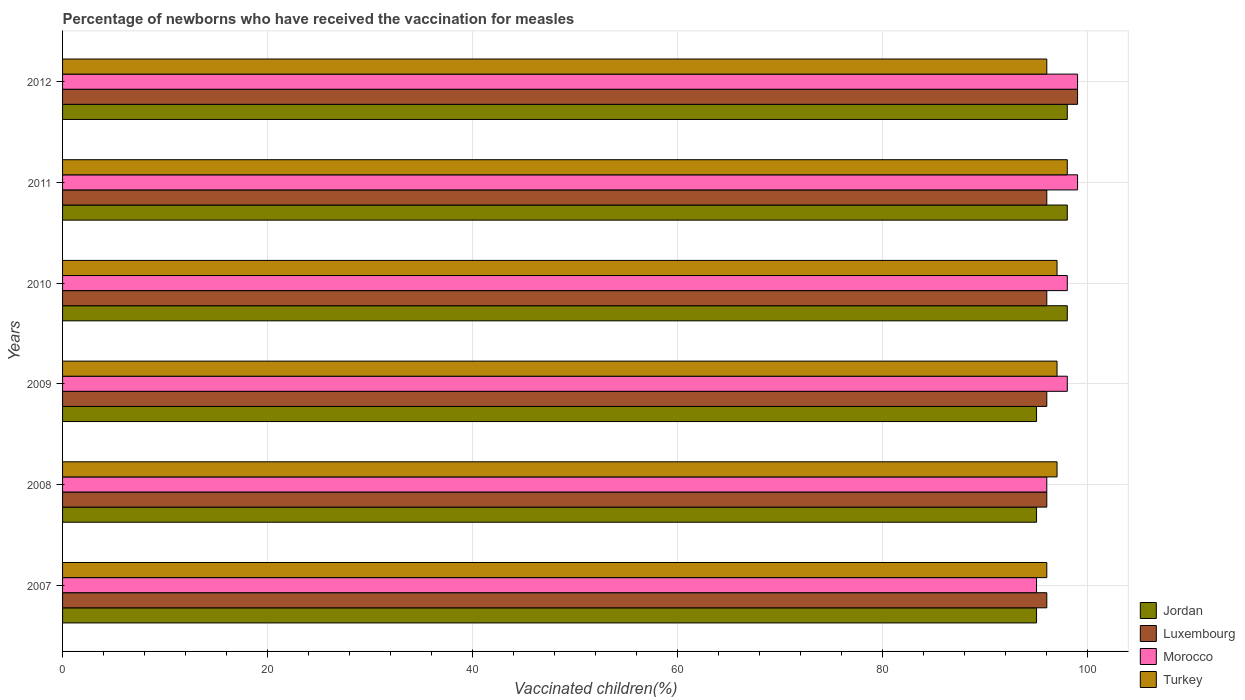How many different coloured bars are there?
Provide a short and direct response. 4. Are the number of bars on each tick of the Y-axis equal?
Your answer should be very brief. Yes. How many bars are there on the 2nd tick from the top?
Keep it short and to the point. 4. In how many cases, is the number of bars for a given year not equal to the number of legend labels?
Offer a terse response. 0. What is the percentage of vaccinated children in Turkey in 2012?
Offer a very short reply. 96. Across all years, what is the maximum percentage of vaccinated children in Turkey?
Your response must be concise. 98. Across all years, what is the minimum percentage of vaccinated children in Luxembourg?
Give a very brief answer. 96. In which year was the percentage of vaccinated children in Morocco maximum?
Your answer should be compact. 2011. In which year was the percentage of vaccinated children in Morocco minimum?
Make the answer very short. 2007. What is the total percentage of vaccinated children in Morocco in the graph?
Your response must be concise. 585. What is the difference between the percentage of vaccinated children in Turkey in 2008 and that in 2012?
Offer a very short reply. 1. What is the average percentage of vaccinated children in Morocco per year?
Your response must be concise. 97.5. In the year 2011, what is the difference between the percentage of vaccinated children in Luxembourg and percentage of vaccinated children in Jordan?
Give a very brief answer. -2. In how many years, is the percentage of vaccinated children in Turkey greater than 60 %?
Ensure brevity in your answer.  6. What is the ratio of the percentage of vaccinated children in Turkey in 2009 to that in 2011?
Provide a short and direct response. 0.99. Is the percentage of vaccinated children in Turkey in 2009 less than that in 2011?
Provide a short and direct response. Yes. What is the difference between the highest and the lowest percentage of vaccinated children in Morocco?
Offer a terse response. 4. In how many years, is the percentage of vaccinated children in Jordan greater than the average percentage of vaccinated children in Jordan taken over all years?
Your response must be concise. 3. Is the sum of the percentage of vaccinated children in Turkey in 2008 and 2012 greater than the maximum percentage of vaccinated children in Morocco across all years?
Offer a very short reply. Yes. What does the 3rd bar from the bottom in 2007 represents?
Offer a terse response. Morocco. Are all the bars in the graph horizontal?
Offer a terse response. Yes. Does the graph contain any zero values?
Offer a terse response. No. Where does the legend appear in the graph?
Offer a terse response. Bottom right. What is the title of the graph?
Provide a succinct answer. Percentage of newborns who have received the vaccination for measles. Does "Macedonia" appear as one of the legend labels in the graph?
Your response must be concise. No. What is the label or title of the X-axis?
Give a very brief answer. Vaccinated children(%). What is the Vaccinated children(%) in Jordan in 2007?
Keep it short and to the point. 95. What is the Vaccinated children(%) of Luxembourg in 2007?
Your answer should be very brief. 96. What is the Vaccinated children(%) of Morocco in 2007?
Your response must be concise. 95. What is the Vaccinated children(%) in Turkey in 2007?
Offer a terse response. 96. What is the Vaccinated children(%) in Luxembourg in 2008?
Provide a succinct answer. 96. What is the Vaccinated children(%) in Morocco in 2008?
Your response must be concise. 96. What is the Vaccinated children(%) of Turkey in 2008?
Provide a short and direct response. 97. What is the Vaccinated children(%) of Jordan in 2009?
Offer a terse response. 95. What is the Vaccinated children(%) in Luxembourg in 2009?
Provide a succinct answer. 96. What is the Vaccinated children(%) in Morocco in 2009?
Provide a succinct answer. 98. What is the Vaccinated children(%) of Turkey in 2009?
Your response must be concise. 97. What is the Vaccinated children(%) in Luxembourg in 2010?
Offer a very short reply. 96. What is the Vaccinated children(%) of Turkey in 2010?
Keep it short and to the point. 97. What is the Vaccinated children(%) in Jordan in 2011?
Your response must be concise. 98. What is the Vaccinated children(%) of Luxembourg in 2011?
Your answer should be very brief. 96. What is the Vaccinated children(%) of Morocco in 2011?
Your answer should be very brief. 99. What is the Vaccinated children(%) in Luxembourg in 2012?
Keep it short and to the point. 99. What is the Vaccinated children(%) in Morocco in 2012?
Your response must be concise. 99. What is the Vaccinated children(%) of Turkey in 2012?
Your answer should be very brief. 96. Across all years, what is the maximum Vaccinated children(%) in Luxembourg?
Offer a very short reply. 99. Across all years, what is the maximum Vaccinated children(%) in Morocco?
Your answer should be very brief. 99. Across all years, what is the maximum Vaccinated children(%) in Turkey?
Provide a short and direct response. 98. Across all years, what is the minimum Vaccinated children(%) of Luxembourg?
Offer a very short reply. 96. Across all years, what is the minimum Vaccinated children(%) in Morocco?
Offer a very short reply. 95. Across all years, what is the minimum Vaccinated children(%) in Turkey?
Offer a very short reply. 96. What is the total Vaccinated children(%) in Jordan in the graph?
Give a very brief answer. 579. What is the total Vaccinated children(%) in Luxembourg in the graph?
Keep it short and to the point. 579. What is the total Vaccinated children(%) in Morocco in the graph?
Keep it short and to the point. 585. What is the total Vaccinated children(%) of Turkey in the graph?
Provide a short and direct response. 581. What is the difference between the Vaccinated children(%) in Turkey in 2007 and that in 2009?
Provide a short and direct response. -1. What is the difference between the Vaccinated children(%) of Jordan in 2007 and that in 2010?
Provide a succinct answer. -3. What is the difference between the Vaccinated children(%) of Luxembourg in 2007 and that in 2011?
Ensure brevity in your answer.  0. What is the difference between the Vaccinated children(%) of Turkey in 2007 and that in 2011?
Your answer should be compact. -2. What is the difference between the Vaccinated children(%) of Luxembourg in 2007 and that in 2012?
Provide a succinct answer. -3. What is the difference between the Vaccinated children(%) in Morocco in 2007 and that in 2012?
Your answer should be very brief. -4. What is the difference between the Vaccinated children(%) of Turkey in 2007 and that in 2012?
Your answer should be compact. 0. What is the difference between the Vaccinated children(%) in Jordan in 2008 and that in 2009?
Offer a terse response. 0. What is the difference between the Vaccinated children(%) in Luxembourg in 2008 and that in 2009?
Your answer should be very brief. 0. What is the difference between the Vaccinated children(%) of Morocco in 2008 and that in 2010?
Keep it short and to the point. -2. What is the difference between the Vaccinated children(%) in Turkey in 2008 and that in 2010?
Ensure brevity in your answer.  0. What is the difference between the Vaccinated children(%) in Jordan in 2008 and that in 2011?
Your response must be concise. -3. What is the difference between the Vaccinated children(%) of Luxembourg in 2008 and that in 2011?
Offer a very short reply. 0. What is the difference between the Vaccinated children(%) of Turkey in 2008 and that in 2011?
Offer a very short reply. -1. What is the difference between the Vaccinated children(%) in Luxembourg in 2008 and that in 2012?
Make the answer very short. -3. What is the difference between the Vaccinated children(%) of Morocco in 2008 and that in 2012?
Ensure brevity in your answer.  -3. What is the difference between the Vaccinated children(%) of Turkey in 2009 and that in 2010?
Provide a short and direct response. 0. What is the difference between the Vaccinated children(%) in Jordan in 2009 and that in 2011?
Provide a short and direct response. -3. What is the difference between the Vaccinated children(%) of Luxembourg in 2009 and that in 2011?
Make the answer very short. 0. What is the difference between the Vaccinated children(%) of Morocco in 2009 and that in 2011?
Your answer should be compact. -1. What is the difference between the Vaccinated children(%) in Jordan in 2009 and that in 2012?
Give a very brief answer. -3. What is the difference between the Vaccinated children(%) of Turkey in 2009 and that in 2012?
Your answer should be compact. 1. What is the difference between the Vaccinated children(%) of Luxembourg in 2010 and that in 2011?
Your answer should be compact. 0. What is the difference between the Vaccinated children(%) in Morocco in 2010 and that in 2011?
Provide a short and direct response. -1. What is the difference between the Vaccinated children(%) of Turkey in 2010 and that in 2011?
Your response must be concise. -1. What is the difference between the Vaccinated children(%) in Jordan in 2010 and that in 2012?
Ensure brevity in your answer.  0. What is the difference between the Vaccinated children(%) in Luxembourg in 2010 and that in 2012?
Provide a succinct answer. -3. What is the difference between the Vaccinated children(%) of Turkey in 2010 and that in 2012?
Offer a very short reply. 1. What is the difference between the Vaccinated children(%) in Luxembourg in 2011 and that in 2012?
Your response must be concise. -3. What is the difference between the Vaccinated children(%) in Turkey in 2011 and that in 2012?
Your answer should be very brief. 2. What is the difference between the Vaccinated children(%) of Jordan in 2007 and the Vaccinated children(%) of Luxembourg in 2008?
Your answer should be compact. -1. What is the difference between the Vaccinated children(%) of Luxembourg in 2007 and the Vaccinated children(%) of Morocco in 2008?
Provide a succinct answer. 0. What is the difference between the Vaccinated children(%) in Jordan in 2007 and the Vaccinated children(%) in Luxembourg in 2009?
Make the answer very short. -1. What is the difference between the Vaccinated children(%) of Jordan in 2007 and the Vaccinated children(%) of Morocco in 2009?
Give a very brief answer. -3. What is the difference between the Vaccinated children(%) in Luxembourg in 2007 and the Vaccinated children(%) in Turkey in 2009?
Give a very brief answer. -1. What is the difference between the Vaccinated children(%) in Morocco in 2007 and the Vaccinated children(%) in Turkey in 2009?
Your answer should be very brief. -2. What is the difference between the Vaccinated children(%) in Jordan in 2007 and the Vaccinated children(%) in Morocco in 2010?
Provide a succinct answer. -3. What is the difference between the Vaccinated children(%) in Jordan in 2007 and the Vaccinated children(%) in Turkey in 2010?
Your answer should be compact. -2. What is the difference between the Vaccinated children(%) of Jordan in 2007 and the Vaccinated children(%) of Morocco in 2011?
Provide a succinct answer. -4. What is the difference between the Vaccinated children(%) of Morocco in 2007 and the Vaccinated children(%) of Turkey in 2011?
Keep it short and to the point. -3. What is the difference between the Vaccinated children(%) in Jordan in 2007 and the Vaccinated children(%) in Luxembourg in 2012?
Provide a short and direct response. -4. What is the difference between the Vaccinated children(%) of Jordan in 2007 and the Vaccinated children(%) of Morocco in 2012?
Ensure brevity in your answer.  -4. What is the difference between the Vaccinated children(%) in Luxembourg in 2007 and the Vaccinated children(%) in Turkey in 2012?
Ensure brevity in your answer.  0. What is the difference between the Vaccinated children(%) in Morocco in 2007 and the Vaccinated children(%) in Turkey in 2012?
Make the answer very short. -1. What is the difference between the Vaccinated children(%) of Jordan in 2008 and the Vaccinated children(%) of Luxembourg in 2009?
Provide a succinct answer. -1. What is the difference between the Vaccinated children(%) of Luxembourg in 2008 and the Vaccinated children(%) of Turkey in 2009?
Your response must be concise. -1. What is the difference between the Vaccinated children(%) of Jordan in 2008 and the Vaccinated children(%) of Luxembourg in 2010?
Your answer should be very brief. -1. What is the difference between the Vaccinated children(%) of Jordan in 2008 and the Vaccinated children(%) of Morocco in 2010?
Give a very brief answer. -3. What is the difference between the Vaccinated children(%) in Luxembourg in 2008 and the Vaccinated children(%) in Morocco in 2010?
Your answer should be compact. -2. What is the difference between the Vaccinated children(%) in Jordan in 2008 and the Vaccinated children(%) in Luxembourg in 2011?
Offer a very short reply. -1. What is the difference between the Vaccinated children(%) in Jordan in 2008 and the Vaccinated children(%) in Turkey in 2011?
Ensure brevity in your answer.  -3. What is the difference between the Vaccinated children(%) in Luxembourg in 2008 and the Vaccinated children(%) in Morocco in 2011?
Ensure brevity in your answer.  -3. What is the difference between the Vaccinated children(%) of Luxembourg in 2008 and the Vaccinated children(%) of Turkey in 2011?
Offer a very short reply. -2. What is the difference between the Vaccinated children(%) in Morocco in 2008 and the Vaccinated children(%) in Turkey in 2011?
Your answer should be very brief. -2. What is the difference between the Vaccinated children(%) in Luxembourg in 2008 and the Vaccinated children(%) in Morocco in 2012?
Provide a short and direct response. -3. What is the difference between the Vaccinated children(%) in Luxembourg in 2008 and the Vaccinated children(%) in Turkey in 2012?
Your answer should be very brief. 0. What is the difference between the Vaccinated children(%) of Morocco in 2008 and the Vaccinated children(%) of Turkey in 2012?
Keep it short and to the point. 0. What is the difference between the Vaccinated children(%) of Jordan in 2009 and the Vaccinated children(%) of Turkey in 2010?
Provide a succinct answer. -2. What is the difference between the Vaccinated children(%) in Luxembourg in 2009 and the Vaccinated children(%) in Morocco in 2010?
Provide a succinct answer. -2. What is the difference between the Vaccinated children(%) in Jordan in 2009 and the Vaccinated children(%) in Morocco in 2011?
Ensure brevity in your answer.  -4. What is the difference between the Vaccinated children(%) in Jordan in 2009 and the Vaccinated children(%) in Turkey in 2011?
Ensure brevity in your answer.  -3. What is the difference between the Vaccinated children(%) in Morocco in 2009 and the Vaccinated children(%) in Turkey in 2011?
Provide a short and direct response. 0. What is the difference between the Vaccinated children(%) in Jordan in 2009 and the Vaccinated children(%) in Luxembourg in 2012?
Your response must be concise. -4. What is the difference between the Vaccinated children(%) in Jordan in 2009 and the Vaccinated children(%) in Morocco in 2012?
Keep it short and to the point. -4. What is the difference between the Vaccinated children(%) in Luxembourg in 2009 and the Vaccinated children(%) in Turkey in 2012?
Your response must be concise. 0. What is the difference between the Vaccinated children(%) in Jordan in 2010 and the Vaccinated children(%) in Turkey in 2011?
Make the answer very short. 0. What is the difference between the Vaccinated children(%) in Luxembourg in 2010 and the Vaccinated children(%) in Morocco in 2011?
Provide a succinct answer. -3. What is the difference between the Vaccinated children(%) in Luxembourg in 2010 and the Vaccinated children(%) in Turkey in 2011?
Your response must be concise. -2. What is the difference between the Vaccinated children(%) in Jordan in 2010 and the Vaccinated children(%) in Luxembourg in 2012?
Provide a succinct answer. -1. What is the difference between the Vaccinated children(%) in Luxembourg in 2010 and the Vaccinated children(%) in Morocco in 2012?
Provide a short and direct response. -3. What is the difference between the Vaccinated children(%) in Jordan in 2011 and the Vaccinated children(%) in Luxembourg in 2012?
Provide a short and direct response. -1. What is the difference between the Vaccinated children(%) of Jordan in 2011 and the Vaccinated children(%) of Turkey in 2012?
Your response must be concise. 2. What is the difference between the Vaccinated children(%) in Morocco in 2011 and the Vaccinated children(%) in Turkey in 2012?
Provide a succinct answer. 3. What is the average Vaccinated children(%) of Jordan per year?
Make the answer very short. 96.5. What is the average Vaccinated children(%) of Luxembourg per year?
Make the answer very short. 96.5. What is the average Vaccinated children(%) in Morocco per year?
Make the answer very short. 97.5. What is the average Vaccinated children(%) of Turkey per year?
Ensure brevity in your answer.  96.83. In the year 2007, what is the difference between the Vaccinated children(%) in Jordan and Vaccinated children(%) in Luxembourg?
Your response must be concise. -1. In the year 2007, what is the difference between the Vaccinated children(%) in Jordan and Vaccinated children(%) in Morocco?
Provide a succinct answer. 0. In the year 2007, what is the difference between the Vaccinated children(%) in Luxembourg and Vaccinated children(%) in Morocco?
Provide a short and direct response. 1. In the year 2008, what is the difference between the Vaccinated children(%) in Jordan and Vaccinated children(%) in Luxembourg?
Your answer should be compact. -1. In the year 2008, what is the difference between the Vaccinated children(%) in Jordan and Vaccinated children(%) in Morocco?
Offer a very short reply. -1. In the year 2008, what is the difference between the Vaccinated children(%) of Jordan and Vaccinated children(%) of Turkey?
Your response must be concise. -2. In the year 2008, what is the difference between the Vaccinated children(%) in Luxembourg and Vaccinated children(%) in Morocco?
Provide a short and direct response. 0. In the year 2009, what is the difference between the Vaccinated children(%) of Jordan and Vaccinated children(%) of Luxembourg?
Your answer should be compact. -1. In the year 2009, what is the difference between the Vaccinated children(%) in Jordan and Vaccinated children(%) in Morocco?
Provide a short and direct response. -3. In the year 2009, what is the difference between the Vaccinated children(%) in Luxembourg and Vaccinated children(%) in Morocco?
Offer a very short reply. -2. In the year 2009, what is the difference between the Vaccinated children(%) of Luxembourg and Vaccinated children(%) of Turkey?
Give a very brief answer. -1. In the year 2010, what is the difference between the Vaccinated children(%) in Jordan and Vaccinated children(%) in Luxembourg?
Make the answer very short. 2. In the year 2010, what is the difference between the Vaccinated children(%) of Jordan and Vaccinated children(%) of Turkey?
Keep it short and to the point. 1. In the year 2010, what is the difference between the Vaccinated children(%) in Luxembourg and Vaccinated children(%) in Turkey?
Offer a terse response. -1. In the year 2010, what is the difference between the Vaccinated children(%) of Morocco and Vaccinated children(%) of Turkey?
Your response must be concise. 1. In the year 2012, what is the difference between the Vaccinated children(%) of Luxembourg and Vaccinated children(%) of Morocco?
Provide a short and direct response. 0. What is the ratio of the Vaccinated children(%) in Jordan in 2007 to that in 2008?
Give a very brief answer. 1. What is the ratio of the Vaccinated children(%) in Luxembourg in 2007 to that in 2008?
Give a very brief answer. 1. What is the ratio of the Vaccinated children(%) of Morocco in 2007 to that in 2008?
Provide a short and direct response. 0.99. What is the ratio of the Vaccinated children(%) of Turkey in 2007 to that in 2008?
Offer a terse response. 0.99. What is the ratio of the Vaccinated children(%) of Jordan in 2007 to that in 2009?
Your response must be concise. 1. What is the ratio of the Vaccinated children(%) of Luxembourg in 2007 to that in 2009?
Offer a very short reply. 1. What is the ratio of the Vaccinated children(%) in Morocco in 2007 to that in 2009?
Give a very brief answer. 0.97. What is the ratio of the Vaccinated children(%) in Jordan in 2007 to that in 2010?
Your answer should be very brief. 0.97. What is the ratio of the Vaccinated children(%) in Morocco in 2007 to that in 2010?
Keep it short and to the point. 0.97. What is the ratio of the Vaccinated children(%) of Turkey in 2007 to that in 2010?
Provide a succinct answer. 0.99. What is the ratio of the Vaccinated children(%) in Jordan in 2007 to that in 2011?
Provide a short and direct response. 0.97. What is the ratio of the Vaccinated children(%) in Luxembourg in 2007 to that in 2011?
Offer a very short reply. 1. What is the ratio of the Vaccinated children(%) of Morocco in 2007 to that in 2011?
Provide a succinct answer. 0.96. What is the ratio of the Vaccinated children(%) of Turkey in 2007 to that in 2011?
Your answer should be very brief. 0.98. What is the ratio of the Vaccinated children(%) of Jordan in 2007 to that in 2012?
Your answer should be very brief. 0.97. What is the ratio of the Vaccinated children(%) in Luxembourg in 2007 to that in 2012?
Offer a terse response. 0.97. What is the ratio of the Vaccinated children(%) in Morocco in 2007 to that in 2012?
Your response must be concise. 0.96. What is the ratio of the Vaccinated children(%) in Turkey in 2007 to that in 2012?
Offer a very short reply. 1. What is the ratio of the Vaccinated children(%) of Jordan in 2008 to that in 2009?
Your answer should be compact. 1. What is the ratio of the Vaccinated children(%) of Luxembourg in 2008 to that in 2009?
Offer a very short reply. 1. What is the ratio of the Vaccinated children(%) in Morocco in 2008 to that in 2009?
Provide a succinct answer. 0.98. What is the ratio of the Vaccinated children(%) in Jordan in 2008 to that in 2010?
Offer a very short reply. 0.97. What is the ratio of the Vaccinated children(%) in Luxembourg in 2008 to that in 2010?
Give a very brief answer. 1. What is the ratio of the Vaccinated children(%) of Morocco in 2008 to that in 2010?
Make the answer very short. 0.98. What is the ratio of the Vaccinated children(%) in Turkey in 2008 to that in 2010?
Give a very brief answer. 1. What is the ratio of the Vaccinated children(%) in Jordan in 2008 to that in 2011?
Make the answer very short. 0.97. What is the ratio of the Vaccinated children(%) of Morocco in 2008 to that in 2011?
Your response must be concise. 0.97. What is the ratio of the Vaccinated children(%) of Turkey in 2008 to that in 2011?
Offer a terse response. 0.99. What is the ratio of the Vaccinated children(%) of Jordan in 2008 to that in 2012?
Make the answer very short. 0.97. What is the ratio of the Vaccinated children(%) of Luxembourg in 2008 to that in 2012?
Your response must be concise. 0.97. What is the ratio of the Vaccinated children(%) of Morocco in 2008 to that in 2012?
Provide a succinct answer. 0.97. What is the ratio of the Vaccinated children(%) of Turkey in 2008 to that in 2012?
Ensure brevity in your answer.  1.01. What is the ratio of the Vaccinated children(%) in Jordan in 2009 to that in 2010?
Make the answer very short. 0.97. What is the ratio of the Vaccinated children(%) of Luxembourg in 2009 to that in 2010?
Ensure brevity in your answer.  1. What is the ratio of the Vaccinated children(%) of Turkey in 2009 to that in 2010?
Offer a very short reply. 1. What is the ratio of the Vaccinated children(%) of Jordan in 2009 to that in 2011?
Your response must be concise. 0.97. What is the ratio of the Vaccinated children(%) of Luxembourg in 2009 to that in 2011?
Your answer should be compact. 1. What is the ratio of the Vaccinated children(%) in Morocco in 2009 to that in 2011?
Provide a short and direct response. 0.99. What is the ratio of the Vaccinated children(%) in Turkey in 2009 to that in 2011?
Your answer should be compact. 0.99. What is the ratio of the Vaccinated children(%) of Jordan in 2009 to that in 2012?
Your answer should be very brief. 0.97. What is the ratio of the Vaccinated children(%) in Luxembourg in 2009 to that in 2012?
Your response must be concise. 0.97. What is the ratio of the Vaccinated children(%) in Turkey in 2009 to that in 2012?
Provide a short and direct response. 1.01. What is the ratio of the Vaccinated children(%) in Jordan in 2010 to that in 2011?
Your answer should be very brief. 1. What is the ratio of the Vaccinated children(%) of Luxembourg in 2010 to that in 2011?
Provide a succinct answer. 1. What is the ratio of the Vaccinated children(%) in Morocco in 2010 to that in 2011?
Make the answer very short. 0.99. What is the ratio of the Vaccinated children(%) in Luxembourg in 2010 to that in 2012?
Your answer should be compact. 0.97. What is the ratio of the Vaccinated children(%) of Morocco in 2010 to that in 2012?
Keep it short and to the point. 0.99. What is the ratio of the Vaccinated children(%) in Turkey in 2010 to that in 2012?
Give a very brief answer. 1.01. What is the ratio of the Vaccinated children(%) of Jordan in 2011 to that in 2012?
Provide a succinct answer. 1. What is the ratio of the Vaccinated children(%) of Luxembourg in 2011 to that in 2012?
Your answer should be compact. 0.97. What is the ratio of the Vaccinated children(%) in Morocco in 2011 to that in 2012?
Offer a terse response. 1. What is the ratio of the Vaccinated children(%) in Turkey in 2011 to that in 2012?
Provide a succinct answer. 1.02. What is the difference between the highest and the lowest Vaccinated children(%) of Morocco?
Provide a succinct answer. 4. What is the difference between the highest and the lowest Vaccinated children(%) of Turkey?
Give a very brief answer. 2. 